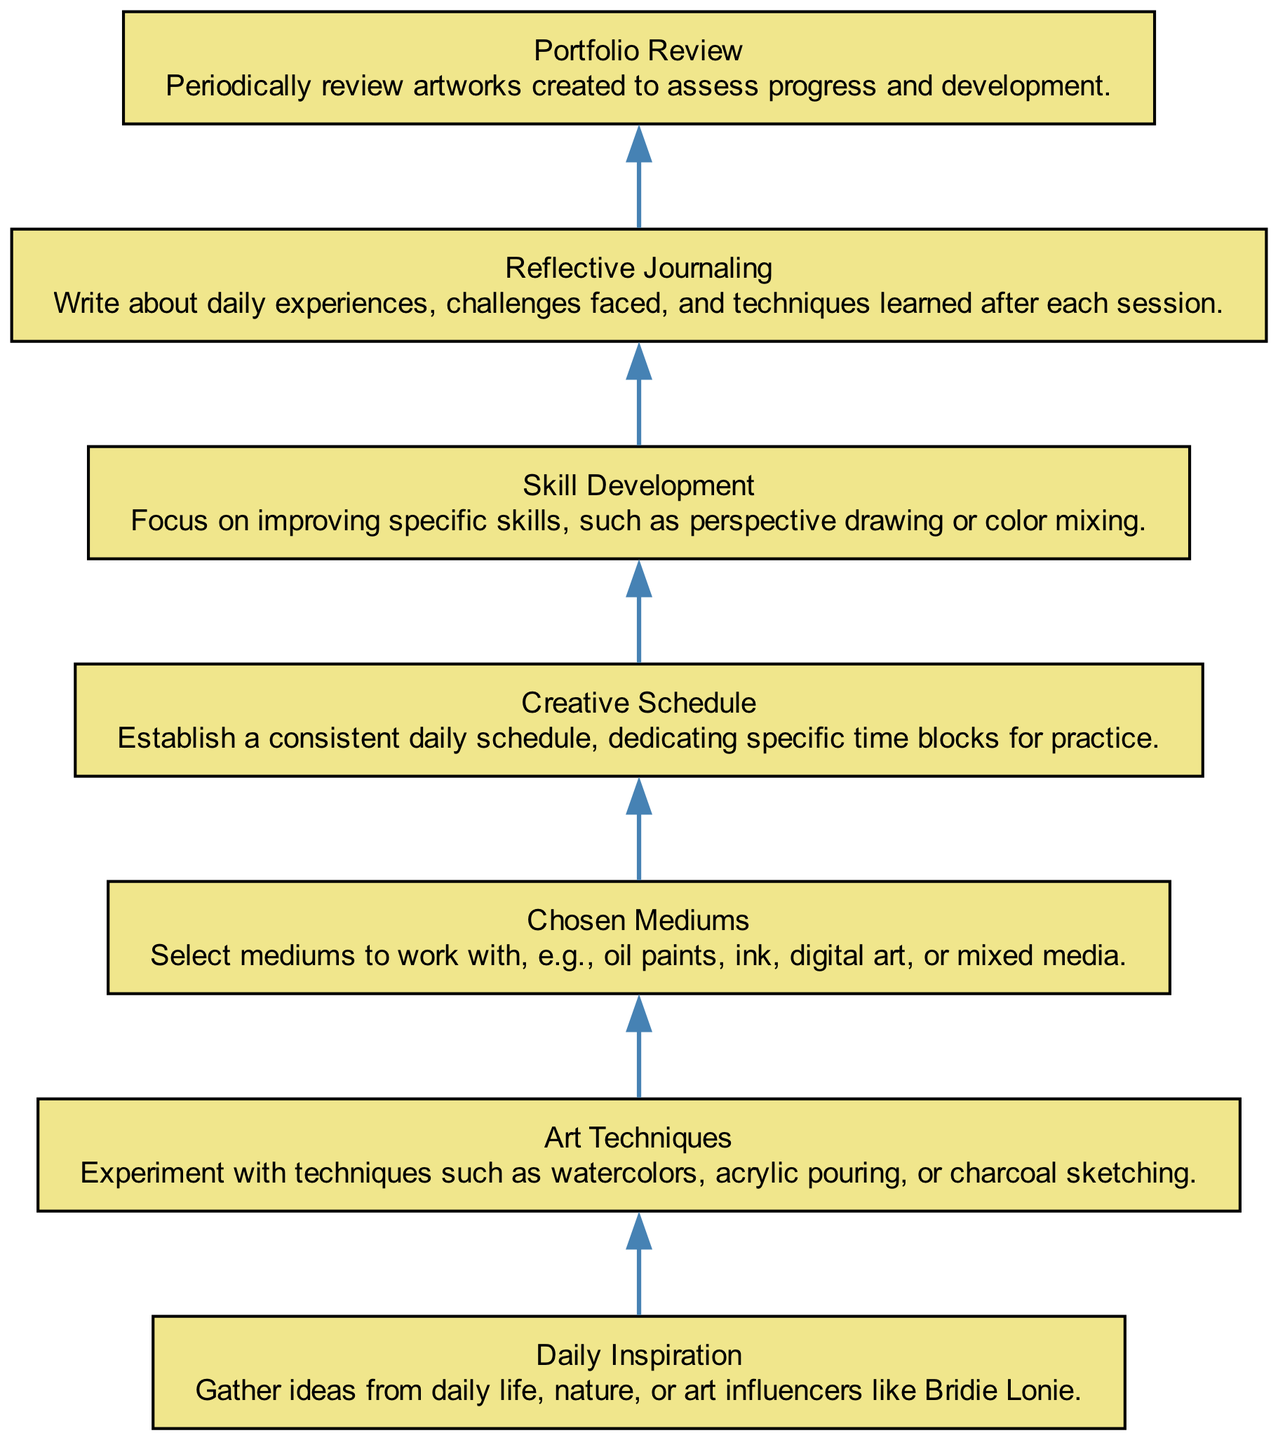What is the first element in the flowchart? The first element is "Daily Inspiration", which is the starting point of the chart. It is positioned at the bottom and serves as the foundation for the subsequent elements.
Answer: Daily Inspiration How many elements are present in the diagram? The diagram contains a total of seven elements, including daily inspiration, art techniques, chosen mediums, creative schedule, skill development, reflective journaling, and portfolio review.
Answer: Seven Which element comes immediately after "Creative Schedule"? "Skill Development" comes immediately after "Creative Schedule," indicating that after establishing a schedule, the focus shifts to improving specific skills in art.
Answer: Skill Development What are the potential mediums to choose from according to the diagram? The potential mediums mentioned in the diagram include oil paints, ink, digital art, or mixed media, as detailed under the "Chosen Mediums" element.
Answer: Oil paints, ink, digital art, mixed media What is the purpose of "Reflective Journaling"? The purpose of "Reflective Journaling" is to write about daily experiences, challenges faced, and techniques learned after each session, fostering self-reflection and growth.
Answer: To write about daily experiences Explain the relationship between "Daily Inspiration" and "Art Techniques." "Art Techniques" follows "Daily Inspiration" in the diagram. This relationship suggests that the gathered ideas and inspirations inform and lead to the experimentation with various art techniques.
Answer: "Art Techniques" follows "Daily Inspiration" What is the final process in the flowchart? The final process in the flowchart is "Portfolio Review", which involves assessing the artworks created periodically to track progress and development as an artist.
Answer: Portfolio Review 